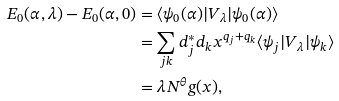<formula> <loc_0><loc_0><loc_500><loc_500>E _ { 0 } ( \alpha , \lambda ) - E _ { 0 } ( \alpha , 0 ) & = \langle \psi _ { 0 } ( \alpha ) | V _ { \lambda } | \psi _ { 0 } ( \alpha ) \rangle \\ & = \sum _ { j k } d _ { j } ^ { * } d _ { k } x ^ { q _ { j } + q _ { k } } \langle \psi _ { j } | V _ { \lambda } | \psi _ { k } \rangle \\ & = \lambda N ^ { \theta } g ( x ) ,</formula> 